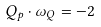Convert formula to latex. <formula><loc_0><loc_0><loc_500><loc_500>Q _ { p } \cdot \omega _ { Q } = - 2</formula> 